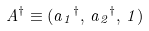Convert formula to latex. <formula><loc_0><loc_0><loc_500><loc_500>A ^ { \dagger } \equiv ( a { _ { 1 } } ^ { \dagger } , \, a { _ { 2 } } ^ { \dagger } , \, 1 )</formula> 